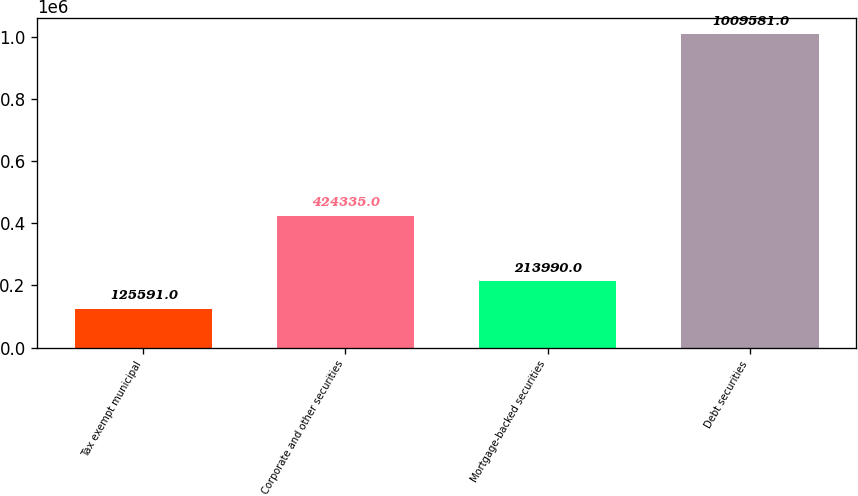<chart> <loc_0><loc_0><loc_500><loc_500><bar_chart><fcel>Tax exempt municipal<fcel>Corporate and other securities<fcel>Mortgage-backed securities<fcel>Debt securities<nl><fcel>125591<fcel>424335<fcel>213990<fcel>1.00958e+06<nl></chart> 